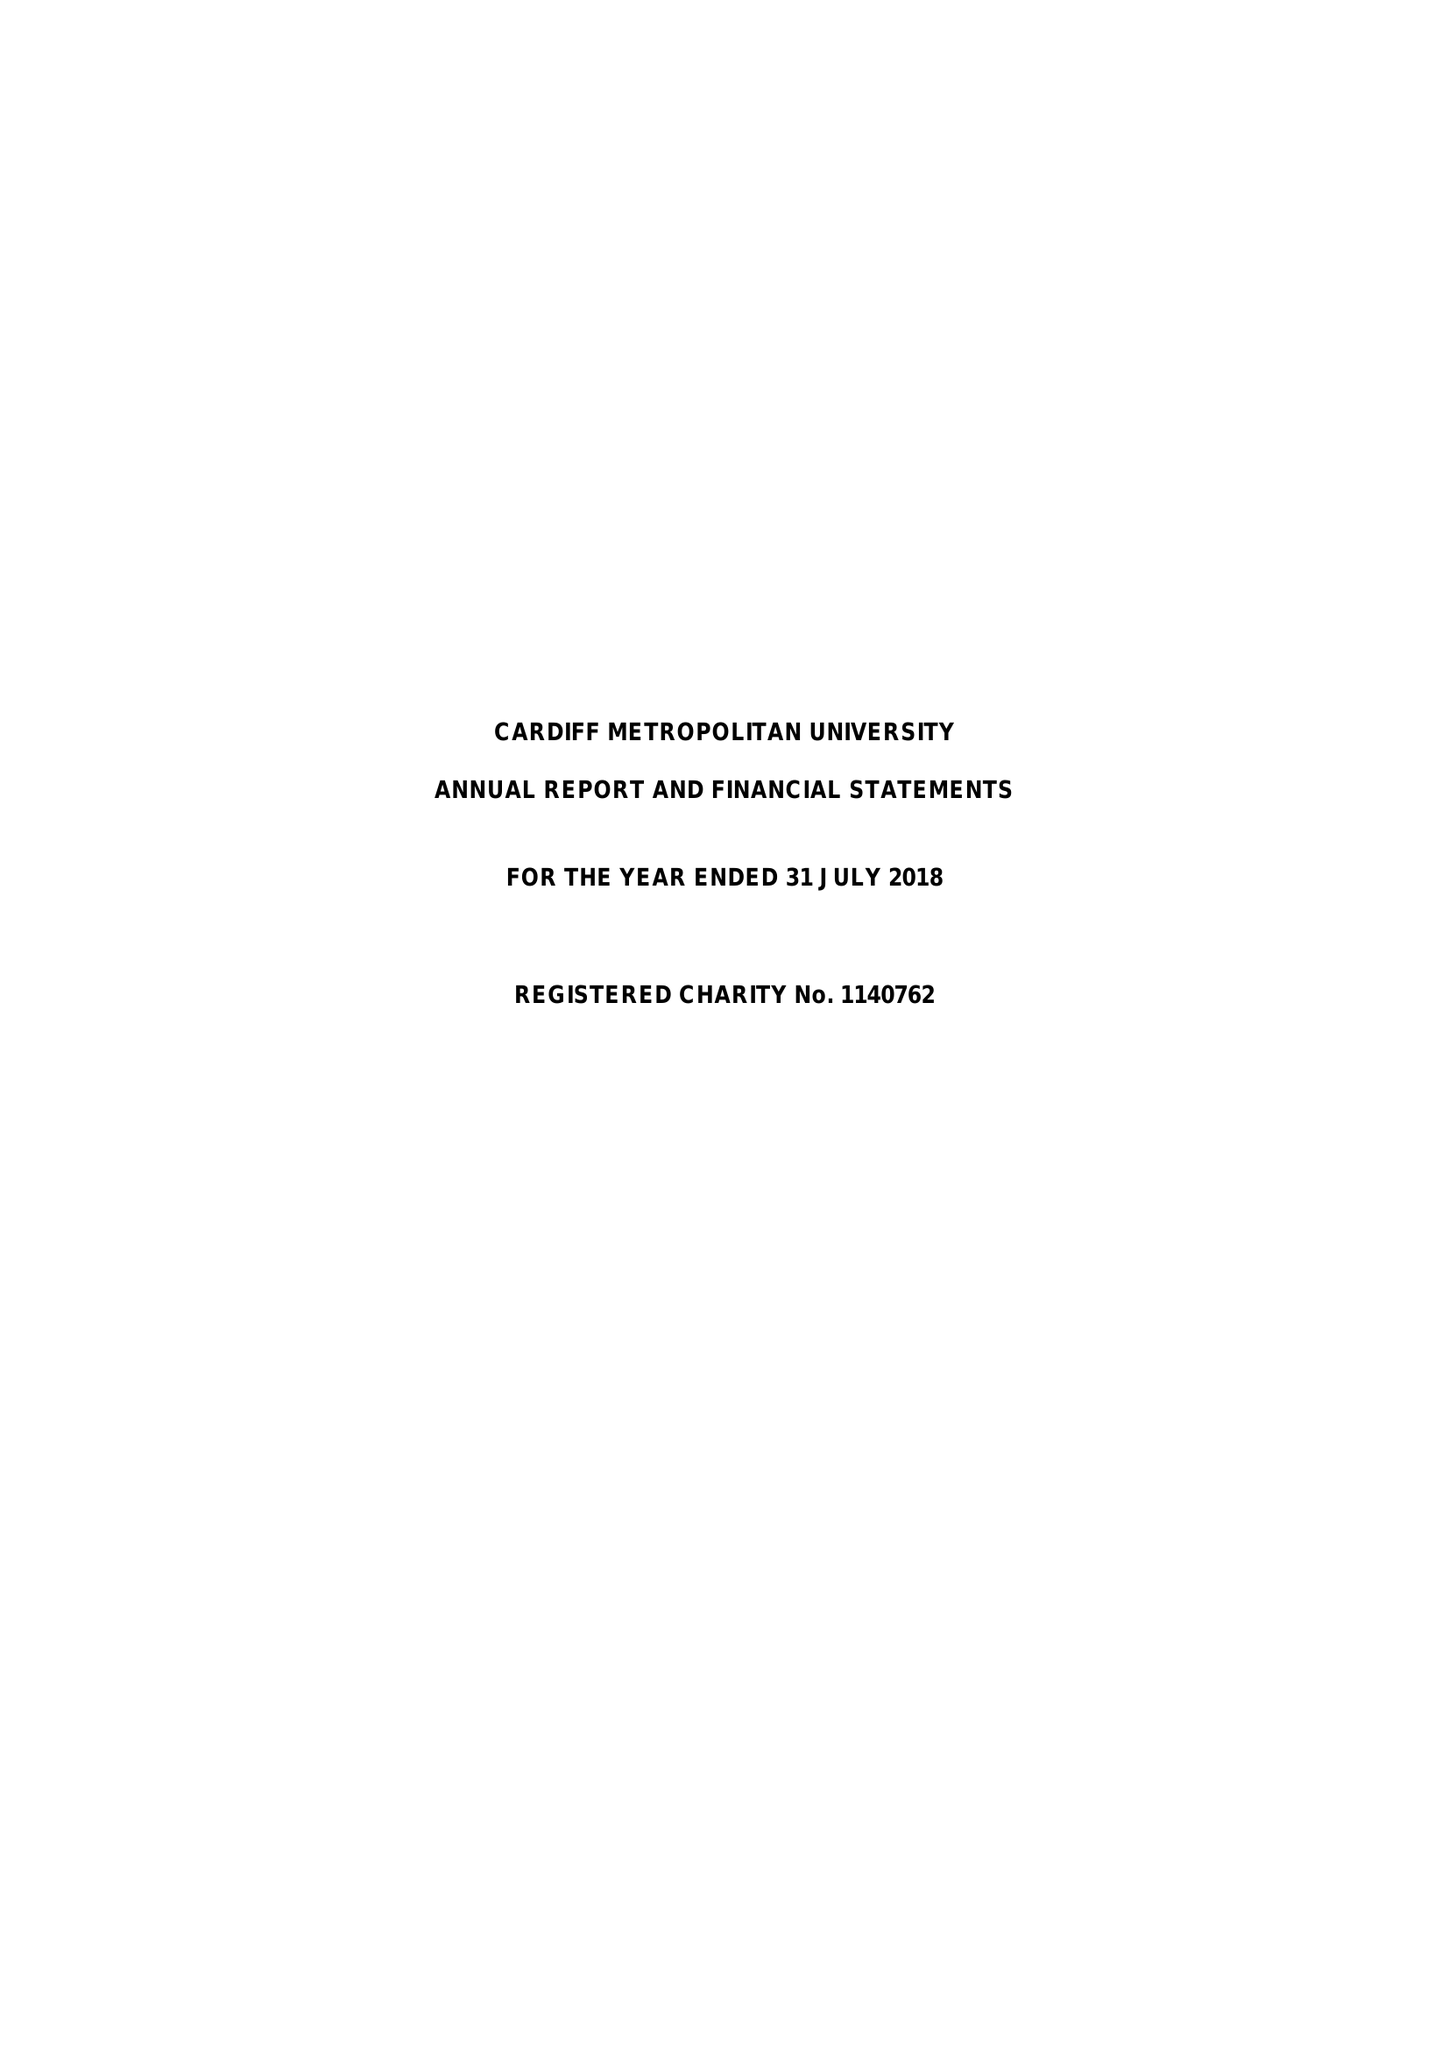What is the value for the address__post_town?
Answer the question using a single word or phrase. CARDIFF 